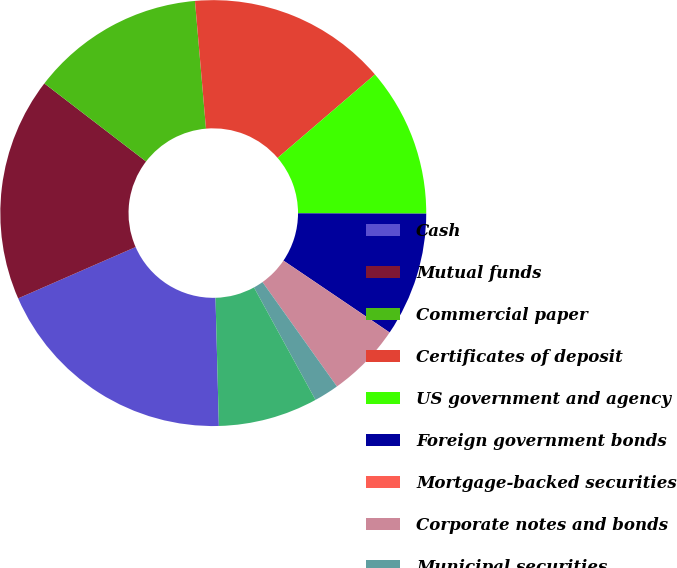Convert chart to OTSL. <chart><loc_0><loc_0><loc_500><loc_500><pie_chart><fcel>Cash<fcel>Mutual funds<fcel>Commercial paper<fcel>Certificates of deposit<fcel>US government and agency<fcel>Foreign government bonds<fcel>Mortgage-backed securities<fcel>Corporate notes and bonds<fcel>Municipal securities<fcel>Common and preferred stock<nl><fcel>18.86%<fcel>16.98%<fcel>13.21%<fcel>15.09%<fcel>11.32%<fcel>9.43%<fcel>0.01%<fcel>5.66%<fcel>1.89%<fcel>7.55%<nl></chart> 